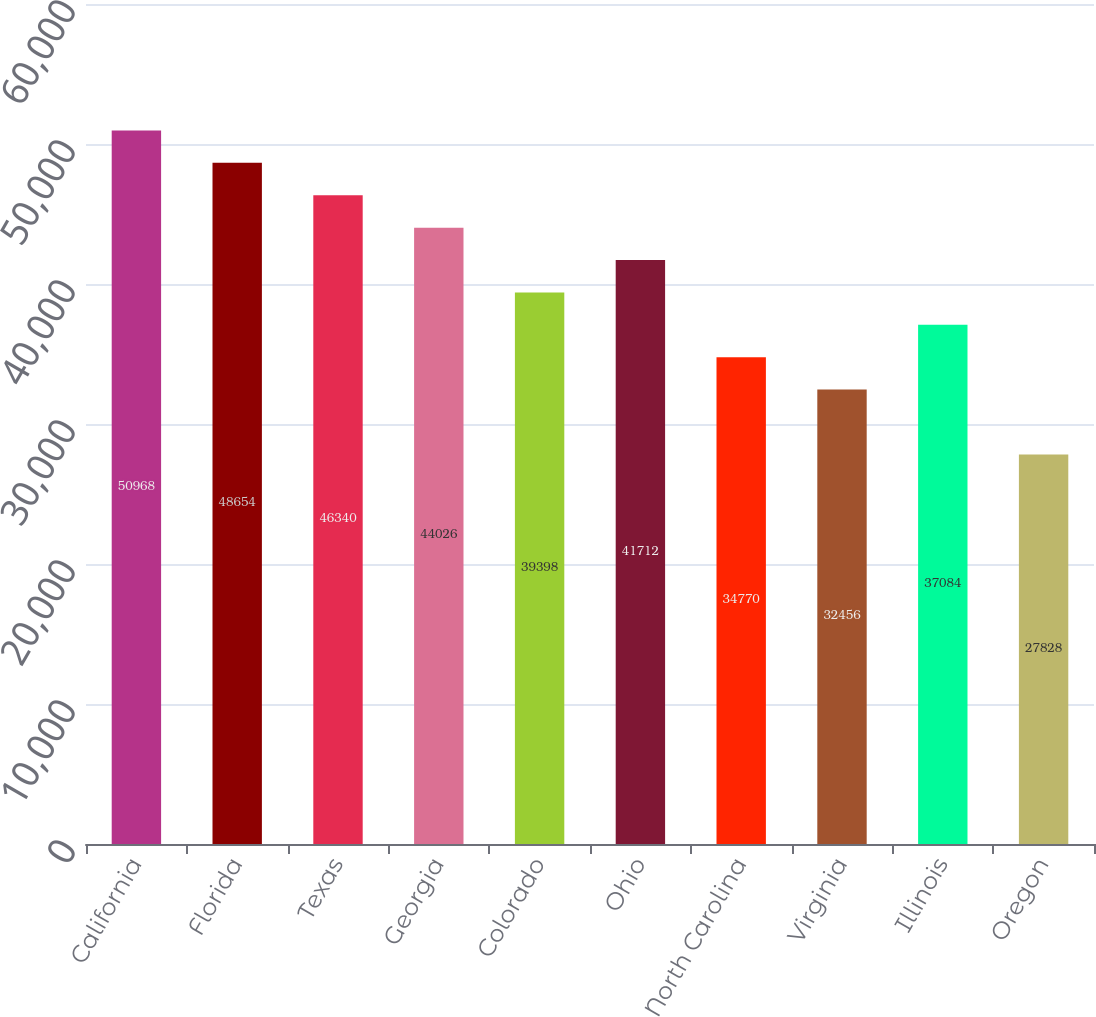Convert chart to OTSL. <chart><loc_0><loc_0><loc_500><loc_500><bar_chart><fcel>California<fcel>Florida<fcel>Texas<fcel>Georgia<fcel>Colorado<fcel>Ohio<fcel>North Carolina<fcel>Virginia<fcel>Illinois<fcel>Oregon<nl><fcel>50968<fcel>48654<fcel>46340<fcel>44026<fcel>39398<fcel>41712<fcel>34770<fcel>32456<fcel>37084<fcel>27828<nl></chart> 